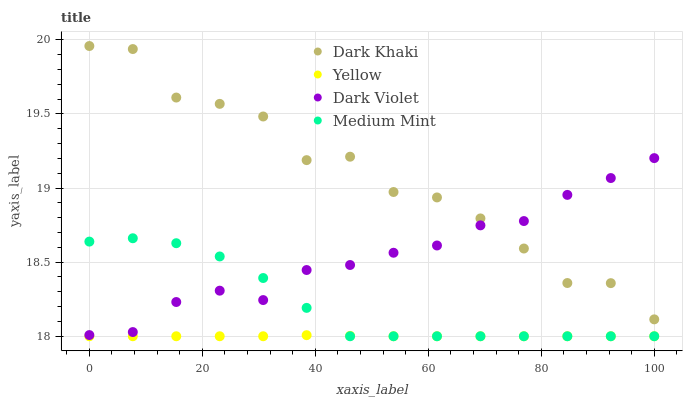Does Yellow have the minimum area under the curve?
Answer yes or no. Yes. Does Dark Khaki have the maximum area under the curve?
Answer yes or no. Yes. Does Medium Mint have the minimum area under the curve?
Answer yes or no. No. Does Medium Mint have the maximum area under the curve?
Answer yes or no. No. Is Yellow the smoothest?
Answer yes or no. Yes. Is Dark Khaki the roughest?
Answer yes or no. Yes. Is Medium Mint the smoothest?
Answer yes or no. No. Is Medium Mint the roughest?
Answer yes or no. No. Does Medium Mint have the lowest value?
Answer yes or no. Yes. Does Dark Violet have the lowest value?
Answer yes or no. No. Does Dark Khaki have the highest value?
Answer yes or no. Yes. Does Medium Mint have the highest value?
Answer yes or no. No. Is Yellow less than Dark Violet?
Answer yes or no. Yes. Is Dark Violet greater than Yellow?
Answer yes or no. Yes. Does Dark Khaki intersect Dark Violet?
Answer yes or no. Yes. Is Dark Khaki less than Dark Violet?
Answer yes or no. No. Is Dark Khaki greater than Dark Violet?
Answer yes or no. No. Does Yellow intersect Dark Violet?
Answer yes or no. No. 